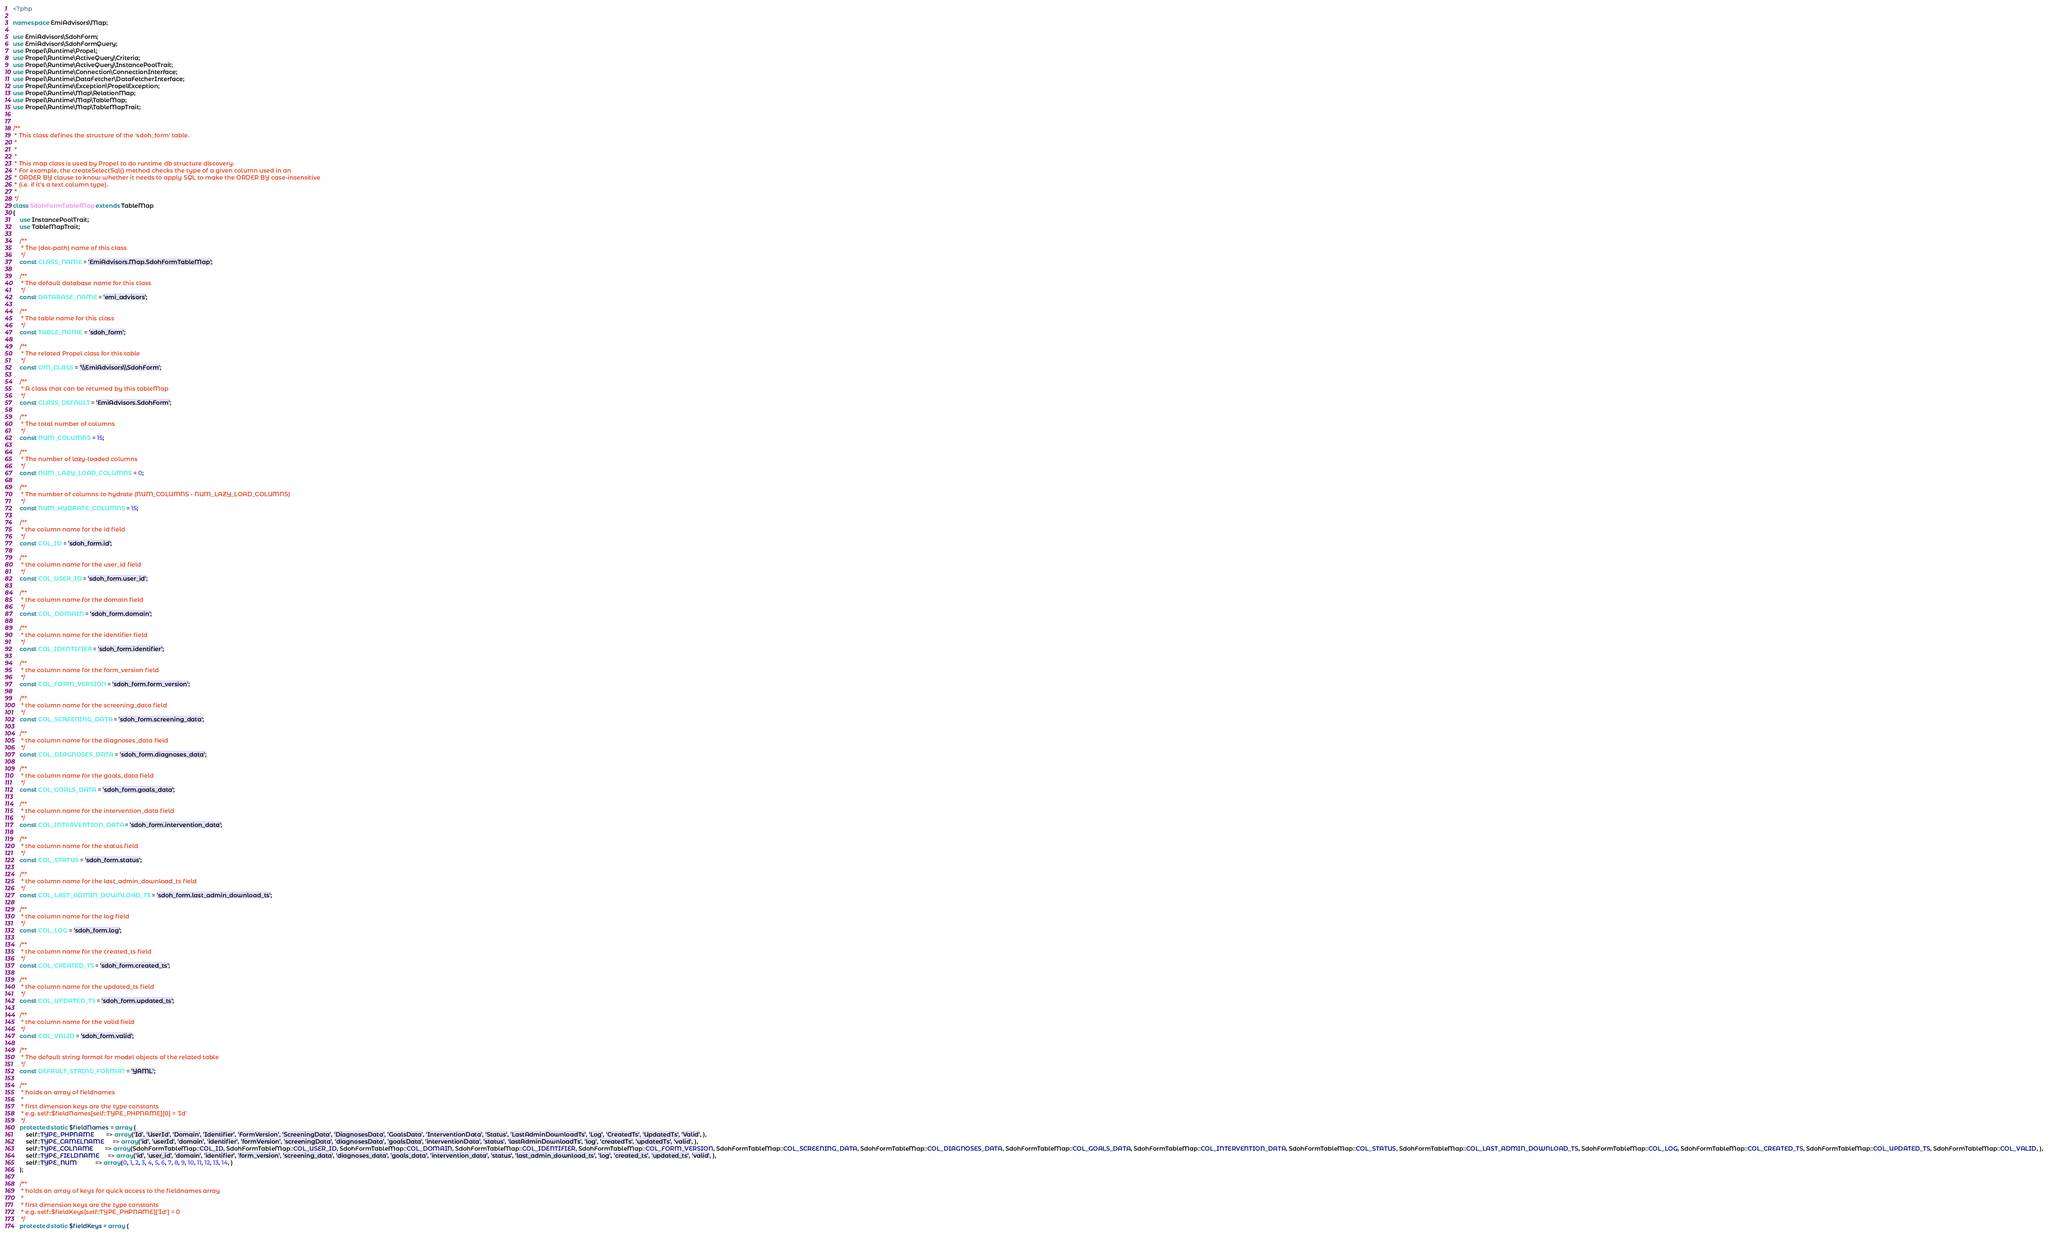<code> <loc_0><loc_0><loc_500><loc_500><_PHP_><?php

namespace EmiAdvisors\Map;

use EmiAdvisors\SdohForm;
use EmiAdvisors\SdohFormQuery;
use Propel\Runtime\Propel;
use Propel\Runtime\ActiveQuery\Criteria;
use Propel\Runtime\ActiveQuery\InstancePoolTrait;
use Propel\Runtime\Connection\ConnectionInterface;
use Propel\Runtime\DataFetcher\DataFetcherInterface;
use Propel\Runtime\Exception\PropelException;
use Propel\Runtime\Map\RelationMap;
use Propel\Runtime\Map\TableMap;
use Propel\Runtime\Map\TableMapTrait;


/**
 * This class defines the structure of the 'sdoh_form' table.
 *
 *
 *
 * This map class is used by Propel to do runtime db structure discovery.
 * For example, the createSelectSql() method checks the type of a given column used in an
 * ORDER BY clause to know whether it needs to apply SQL to make the ORDER BY case-insensitive
 * (i.e. if it's a text column type).
 *
 */
class SdohFormTableMap extends TableMap
{
    use InstancePoolTrait;
    use TableMapTrait;

    /**
     * The (dot-path) name of this class
     */
    const CLASS_NAME = 'EmiAdvisors.Map.SdohFormTableMap';

    /**
     * The default database name for this class
     */
    const DATABASE_NAME = 'emi_advisors';

    /**
     * The table name for this class
     */
    const TABLE_NAME = 'sdoh_form';

    /**
     * The related Propel class for this table
     */
    const OM_CLASS = '\\EmiAdvisors\\SdohForm';

    /**
     * A class that can be returned by this tableMap
     */
    const CLASS_DEFAULT = 'EmiAdvisors.SdohForm';

    /**
     * The total number of columns
     */
    const NUM_COLUMNS = 15;

    /**
     * The number of lazy-loaded columns
     */
    const NUM_LAZY_LOAD_COLUMNS = 0;

    /**
     * The number of columns to hydrate (NUM_COLUMNS - NUM_LAZY_LOAD_COLUMNS)
     */
    const NUM_HYDRATE_COLUMNS = 15;

    /**
     * the column name for the id field
     */
    const COL_ID = 'sdoh_form.id';

    /**
     * the column name for the user_id field
     */
    const COL_USER_ID = 'sdoh_form.user_id';

    /**
     * the column name for the domain field
     */
    const COL_DOMAIN = 'sdoh_form.domain';

    /**
     * the column name for the identifier field
     */
    const COL_IDENTIFIER = 'sdoh_form.identifier';

    /**
     * the column name for the form_version field
     */
    const COL_FORM_VERSION = 'sdoh_form.form_version';

    /**
     * the column name for the screening_data field
     */
    const COL_SCREENING_DATA = 'sdoh_form.screening_data';

    /**
     * the column name for the diagnoses_data field
     */
    const COL_DIAGNOSES_DATA = 'sdoh_form.diagnoses_data';

    /**
     * the column name for the goals_data field
     */
    const COL_GOALS_DATA = 'sdoh_form.goals_data';

    /**
     * the column name for the intervention_data field
     */
    const COL_INTERVENTION_DATA = 'sdoh_form.intervention_data';

    /**
     * the column name for the status field
     */
    const COL_STATUS = 'sdoh_form.status';

    /**
     * the column name for the last_admin_download_ts field
     */
    const COL_LAST_ADMIN_DOWNLOAD_TS = 'sdoh_form.last_admin_download_ts';

    /**
     * the column name for the log field
     */
    const COL_LOG = 'sdoh_form.log';

    /**
     * the column name for the created_ts field
     */
    const COL_CREATED_TS = 'sdoh_form.created_ts';

    /**
     * the column name for the updated_ts field
     */
    const COL_UPDATED_TS = 'sdoh_form.updated_ts';

    /**
     * the column name for the valid field
     */
    const COL_VALID = 'sdoh_form.valid';

    /**
     * The default string format for model objects of the related table
     */
    const DEFAULT_STRING_FORMAT = 'YAML';

    /**
     * holds an array of fieldnames
     *
     * first dimension keys are the type constants
     * e.g. self::$fieldNames[self::TYPE_PHPNAME][0] = 'Id'
     */
    protected static $fieldNames = array (
        self::TYPE_PHPNAME       => array('Id', 'UserId', 'Domain', 'Identifier', 'FormVersion', 'ScreeningData', 'DiagnosesData', 'GoalsData', 'InterventionData', 'Status', 'LastAdminDownloadTs', 'Log', 'CreatedTs', 'UpdatedTs', 'Valid', ),
        self::TYPE_CAMELNAME     => array('id', 'userId', 'domain', 'identifier', 'formVersion', 'screeningData', 'diagnosesData', 'goalsData', 'interventionData', 'status', 'lastAdminDownloadTs', 'log', 'createdTs', 'updatedTs', 'valid', ),
        self::TYPE_COLNAME       => array(SdohFormTableMap::COL_ID, SdohFormTableMap::COL_USER_ID, SdohFormTableMap::COL_DOMAIN, SdohFormTableMap::COL_IDENTIFIER, SdohFormTableMap::COL_FORM_VERSION, SdohFormTableMap::COL_SCREENING_DATA, SdohFormTableMap::COL_DIAGNOSES_DATA, SdohFormTableMap::COL_GOALS_DATA, SdohFormTableMap::COL_INTERVENTION_DATA, SdohFormTableMap::COL_STATUS, SdohFormTableMap::COL_LAST_ADMIN_DOWNLOAD_TS, SdohFormTableMap::COL_LOG, SdohFormTableMap::COL_CREATED_TS, SdohFormTableMap::COL_UPDATED_TS, SdohFormTableMap::COL_VALID, ),
        self::TYPE_FIELDNAME     => array('id', 'user_id', 'domain', 'identifier', 'form_version', 'screening_data', 'diagnoses_data', 'goals_data', 'intervention_data', 'status', 'last_admin_download_ts', 'log', 'created_ts', 'updated_ts', 'valid', ),
        self::TYPE_NUM           => array(0, 1, 2, 3, 4, 5, 6, 7, 8, 9, 10, 11, 12, 13, 14, )
    );

    /**
     * holds an array of keys for quick access to the fieldnames array
     *
     * first dimension keys are the type constants
     * e.g. self::$fieldKeys[self::TYPE_PHPNAME]['Id'] = 0
     */
    protected static $fieldKeys = array (</code> 